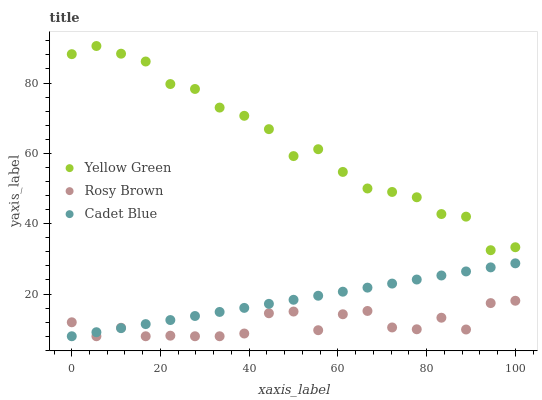Does Rosy Brown have the minimum area under the curve?
Answer yes or no. Yes. Does Yellow Green have the maximum area under the curve?
Answer yes or no. Yes. Does Yellow Green have the minimum area under the curve?
Answer yes or no. No. Does Rosy Brown have the maximum area under the curve?
Answer yes or no. No. Is Cadet Blue the smoothest?
Answer yes or no. Yes. Is Rosy Brown the roughest?
Answer yes or no. Yes. Is Yellow Green the smoothest?
Answer yes or no. No. Is Yellow Green the roughest?
Answer yes or no. No. Does Cadet Blue have the lowest value?
Answer yes or no. Yes. Does Yellow Green have the lowest value?
Answer yes or no. No. Does Yellow Green have the highest value?
Answer yes or no. Yes. Does Rosy Brown have the highest value?
Answer yes or no. No. Is Cadet Blue less than Yellow Green?
Answer yes or no. Yes. Is Yellow Green greater than Rosy Brown?
Answer yes or no. Yes. Does Rosy Brown intersect Cadet Blue?
Answer yes or no. Yes. Is Rosy Brown less than Cadet Blue?
Answer yes or no. No. Is Rosy Brown greater than Cadet Blue?
Answer yes or no. No. Does Cadet Blue intersect Yellow Green?
Answer yes or no. No. 